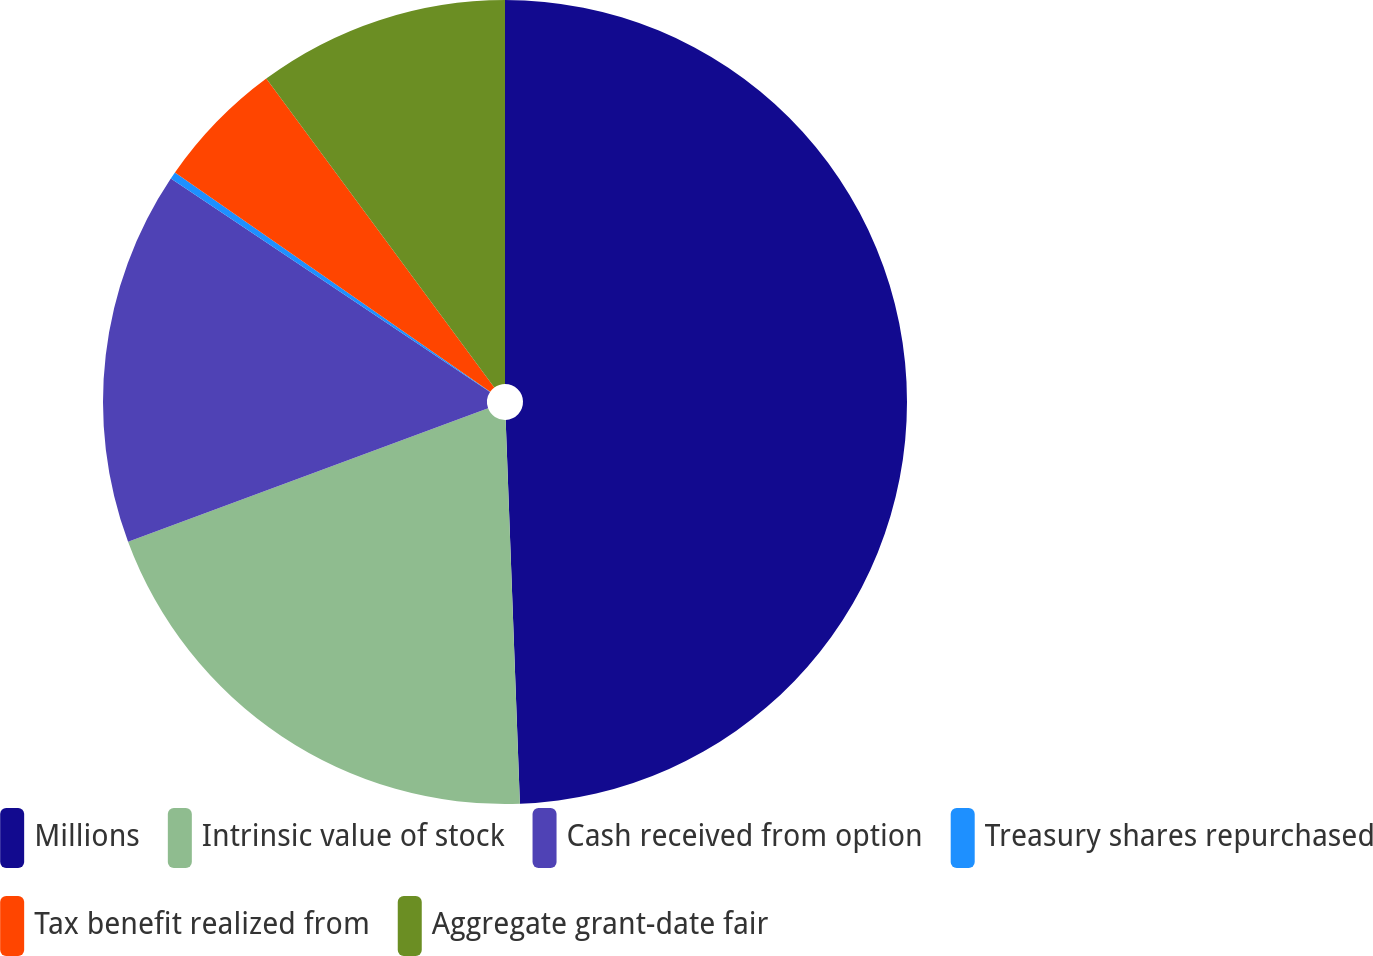<chart> <loc_0><loc_0><loc_500><loc_500><pie_chart><fcel>Millions<fcel>Intrinsic value of stock<fcel>Cash received from option<fcel>Treasury shares repurchased<fcel>Tax benefit realized from<fcel>Aggregate grant-date fair<nl><fcel>49.41%<fcel>19.94%<fcel>15.03%<fcel>0.29%<fcel>5.21%<fcel>10.12%<nl></chart> 